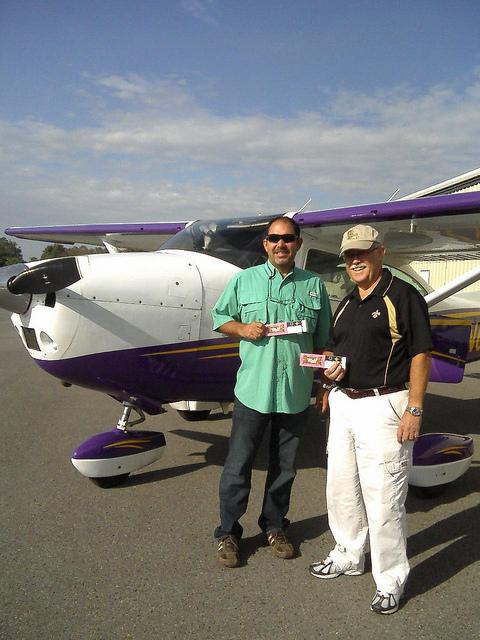What are these men displaying?

Choices:
A) pilots license
B) movie ticket
C) entrance ticket
D) police badge pilots license 